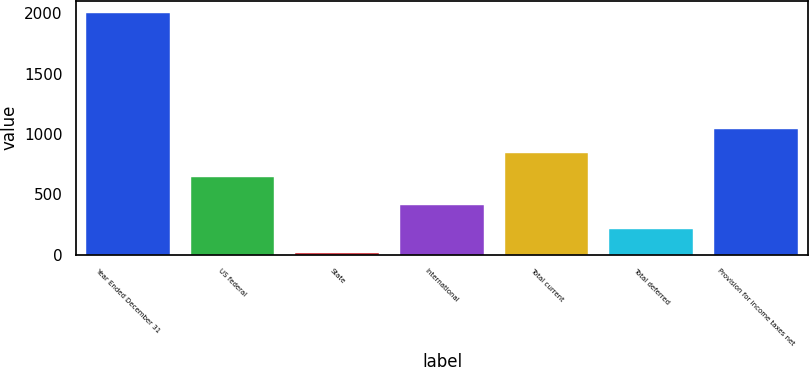Convert chart to OTSL. <chart><loc_0><loc_0><loc_500><loc_500><bar_chart><fcel>Year Ended December 31<fcel>US federal<fcel>State<fcel>International<fcel>Total current<fcel>Total deferred<fcel>Provision for income taxes net<nl><fcel>2006<fcel>642<fcel>12<fcel>410.8<fcel>841.4<fcel>211.4<fcel>1040.8<nl></chart> 